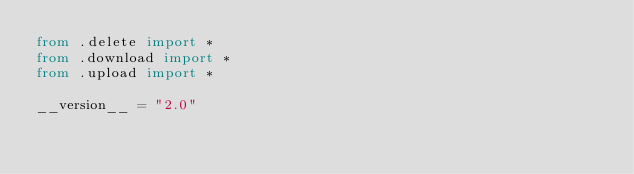Convert code to text. <code><loc_0><loc_0><loc_500><loc_500><_Python_>from .delete import *
from .download import *
from .upload import *

__version__ = "2.0"
</code> 